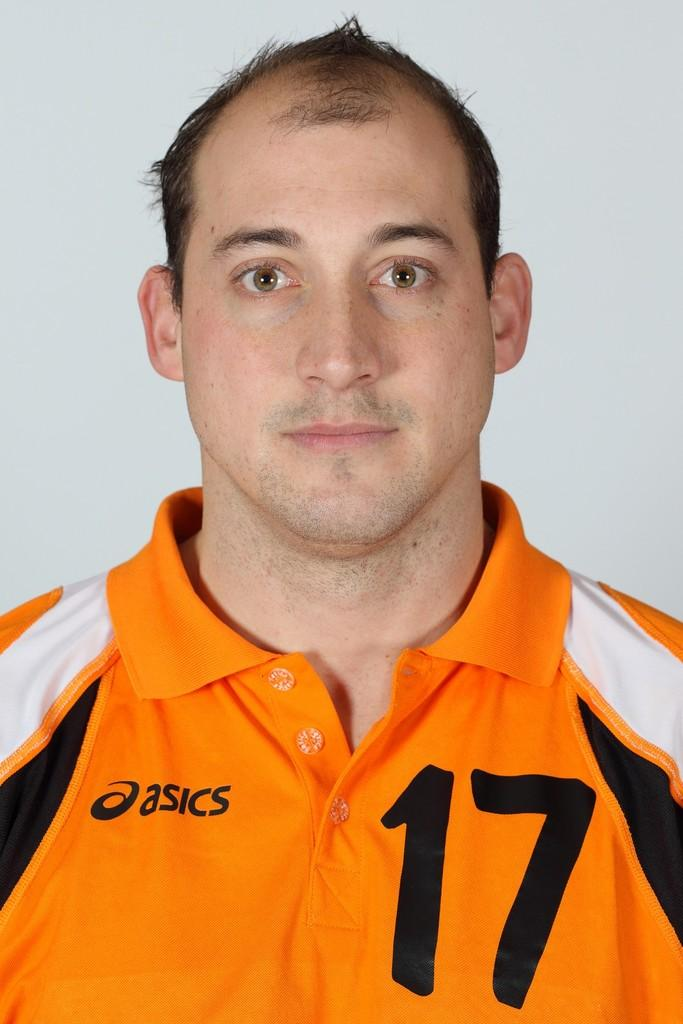<image>
Summarize the visual content of the image. A man is wearing an orange asics shirt. 